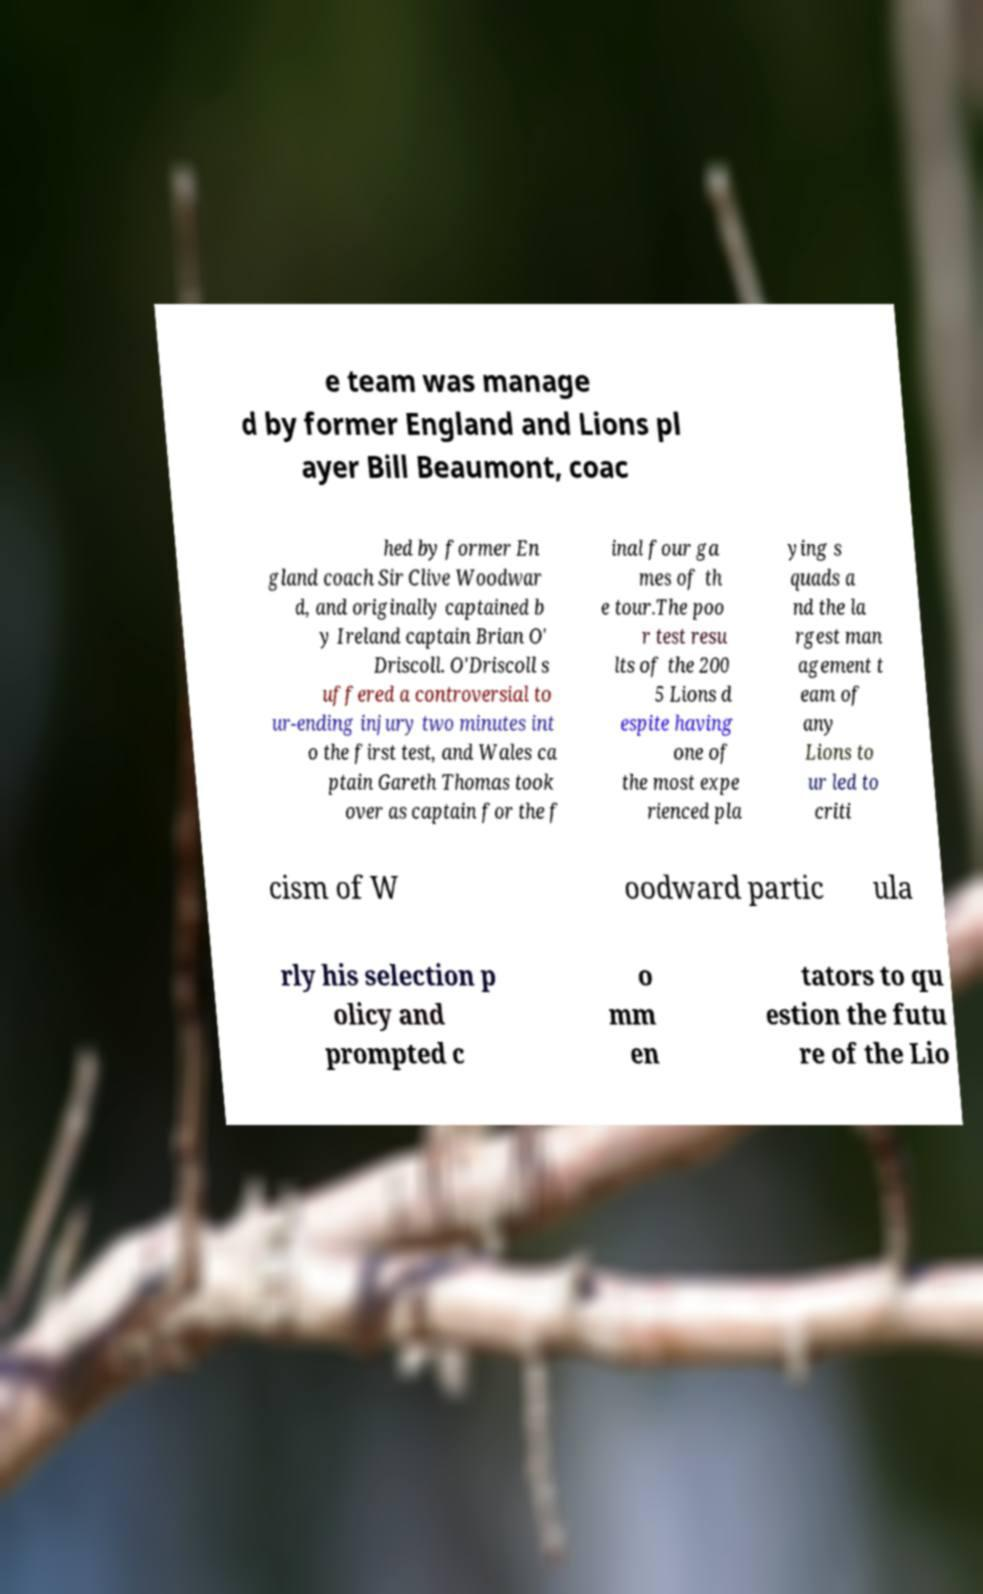Could you extract and type out the text from this image? e team was manage d by former England and Lions pl ayer Bill Beaumont, coac hed by former En gland coach Sir Clive Woodwar d, and originally captained b y Ireland captain Brian O' Driscoll. O'Driscoll s uffered a controversial to ur-ending injury two minutes int o the first test, and Wales ca ptain Gareth Thomas took over as captain for the f inal four ga mes of th e tour.The poo r test resu lts of the 200 5 Lions d espite having one of the most expe rienced pla ying s quads a nd the la rgest man agement t eam of any Lions to ur led to criti cism of W oodward partic ula rly his selection p olicy and prompted c o mm en tators to qu estion the futu re of the Lio 